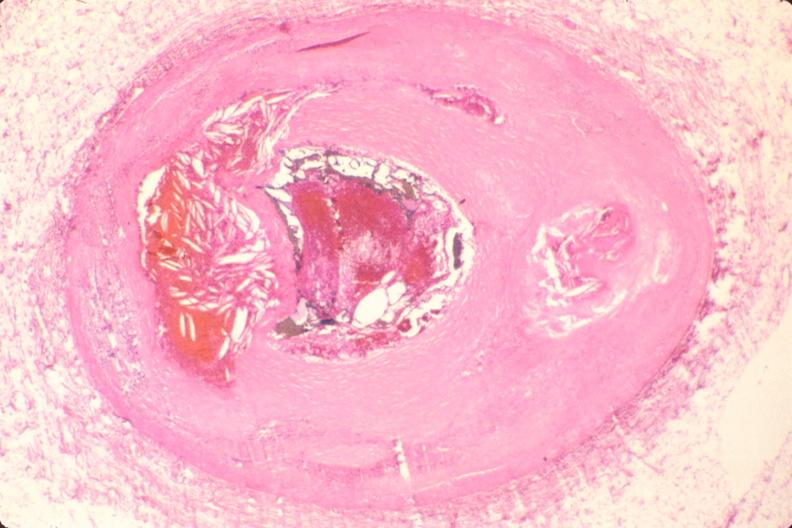does this image show coronary artery atherosclerosis?
Answer the question using a single word or phrase. Yes 